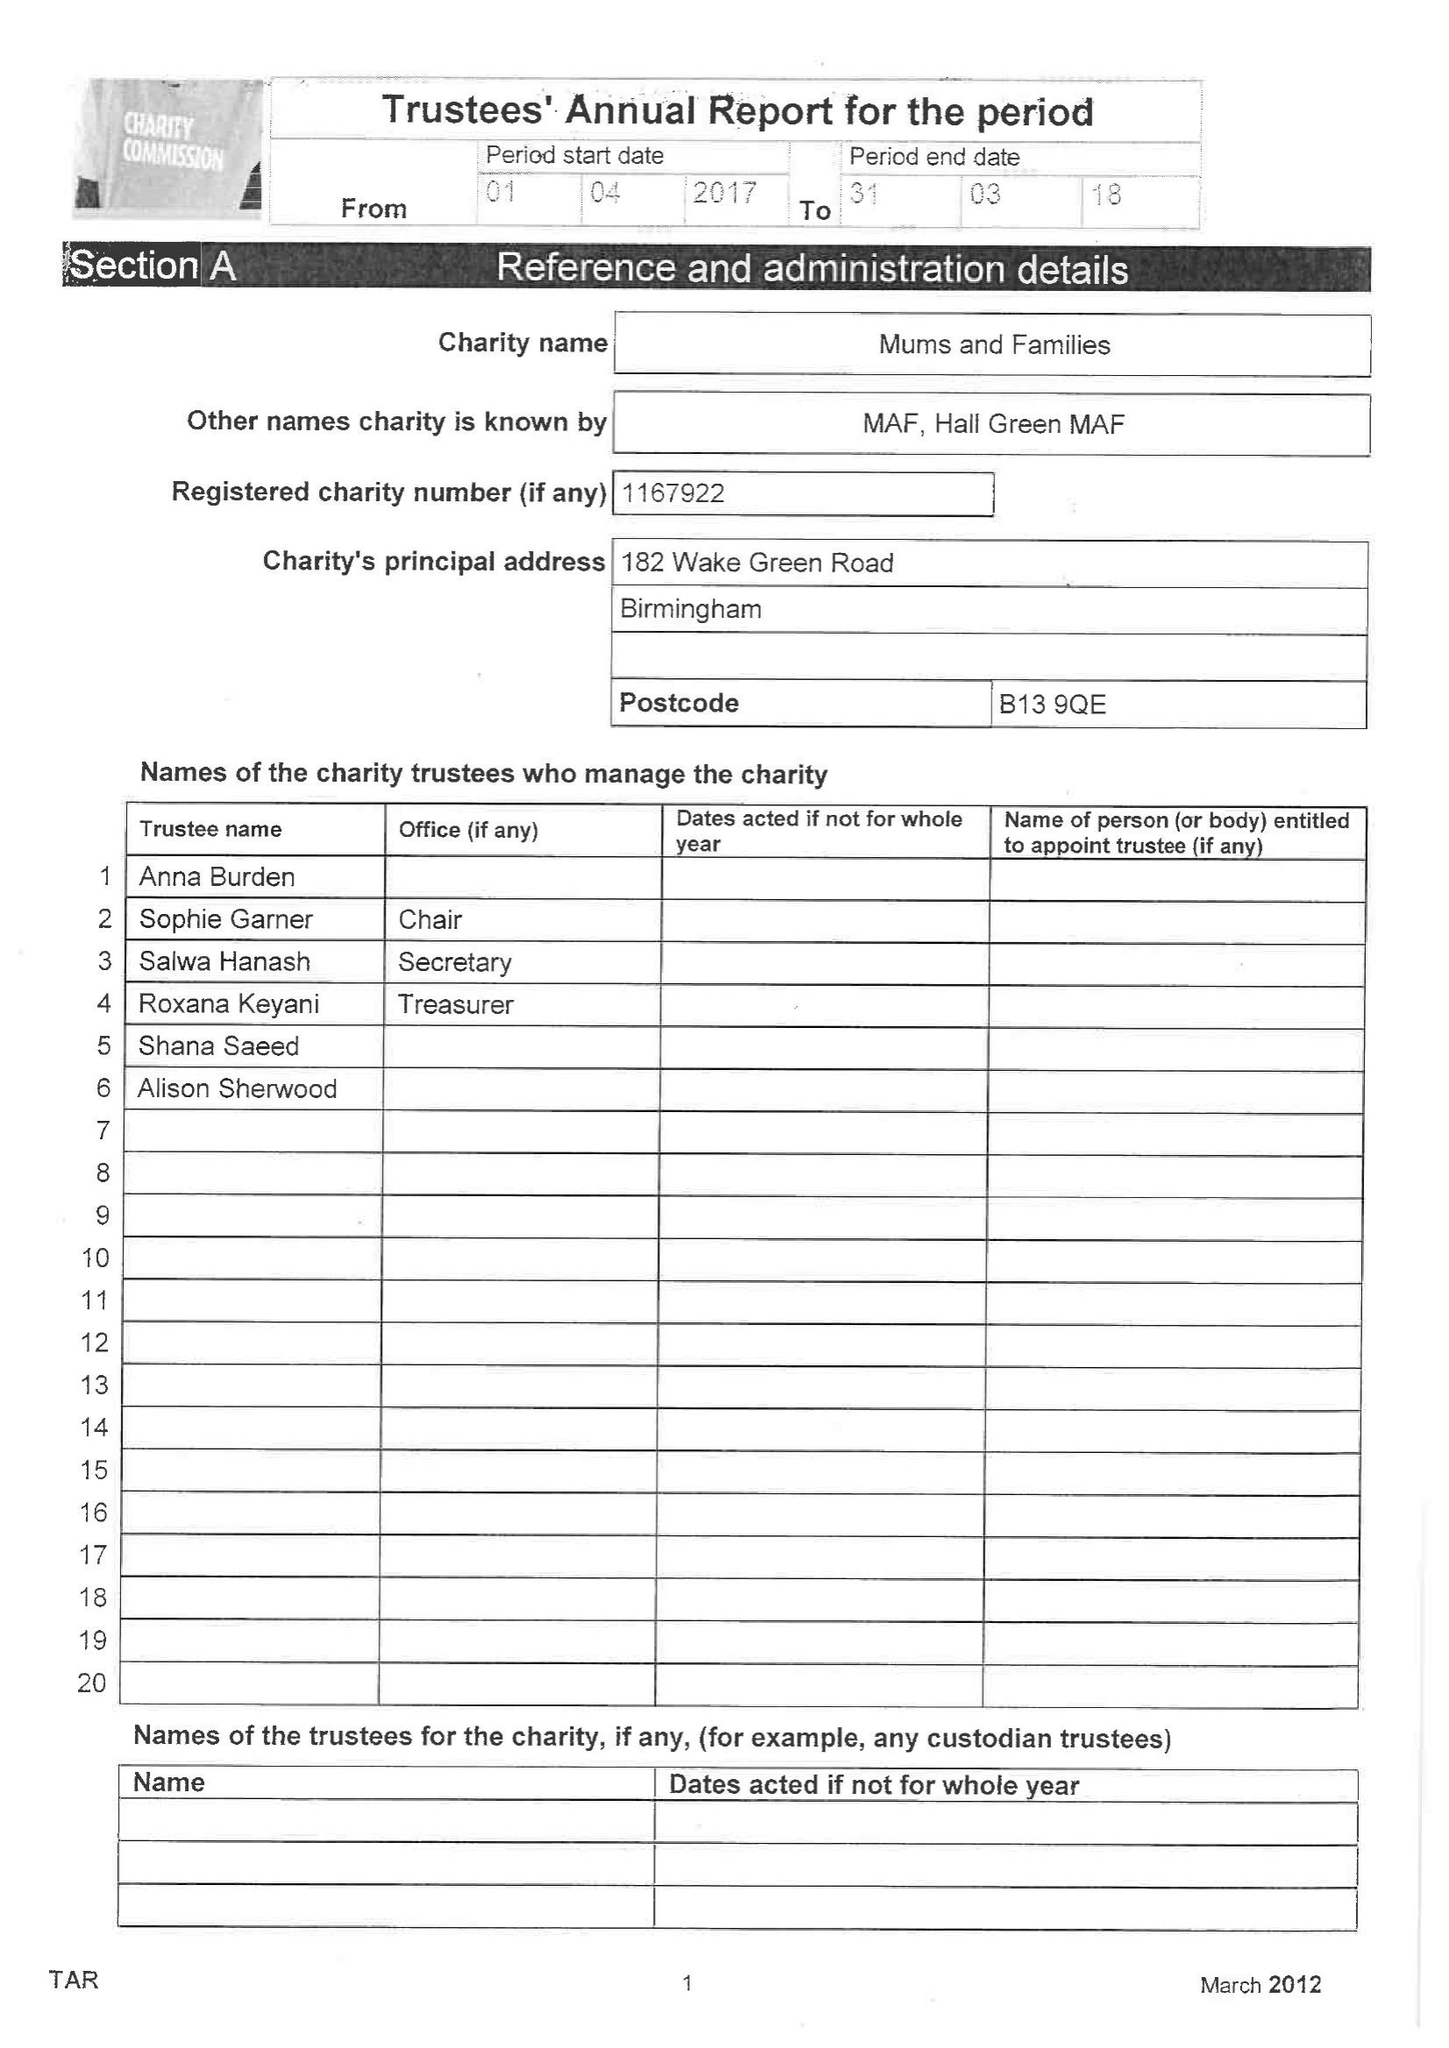What is the value for the charity_number?
Answer the question using a single word or phrase. 1167922 